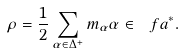Convert formula to latex. <formula><loc_0><loc_0><loc_500><loc_500>\rho = \frac { 1 } { 2 } \sum _ { \alpha \in \Delta ^ { + } } m _ { \alpha } \alpha \in \ f a ^ { * } .</formula> 